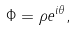Convert formula to latex. <formula><loc_0><loc_0><loc_500><loc_500>\Phi = \rho e ^ { i \theta } ,</formula> 